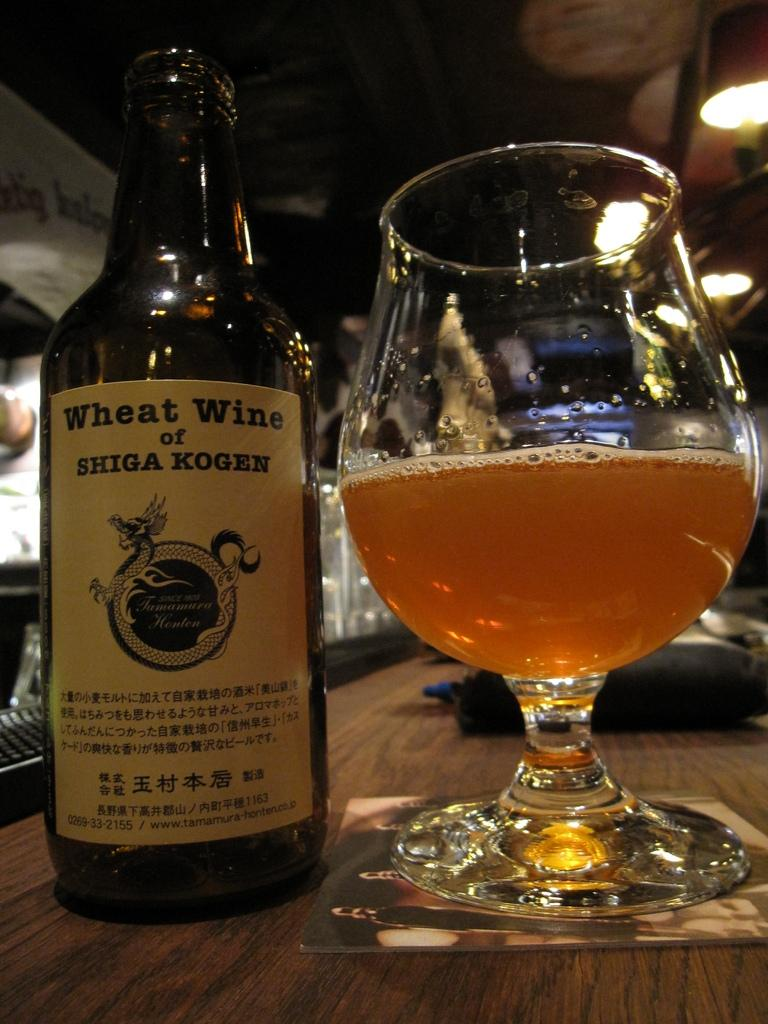Provide a one-sentence caption for the provided image. A large glass next to a bottle of wheat wine. 